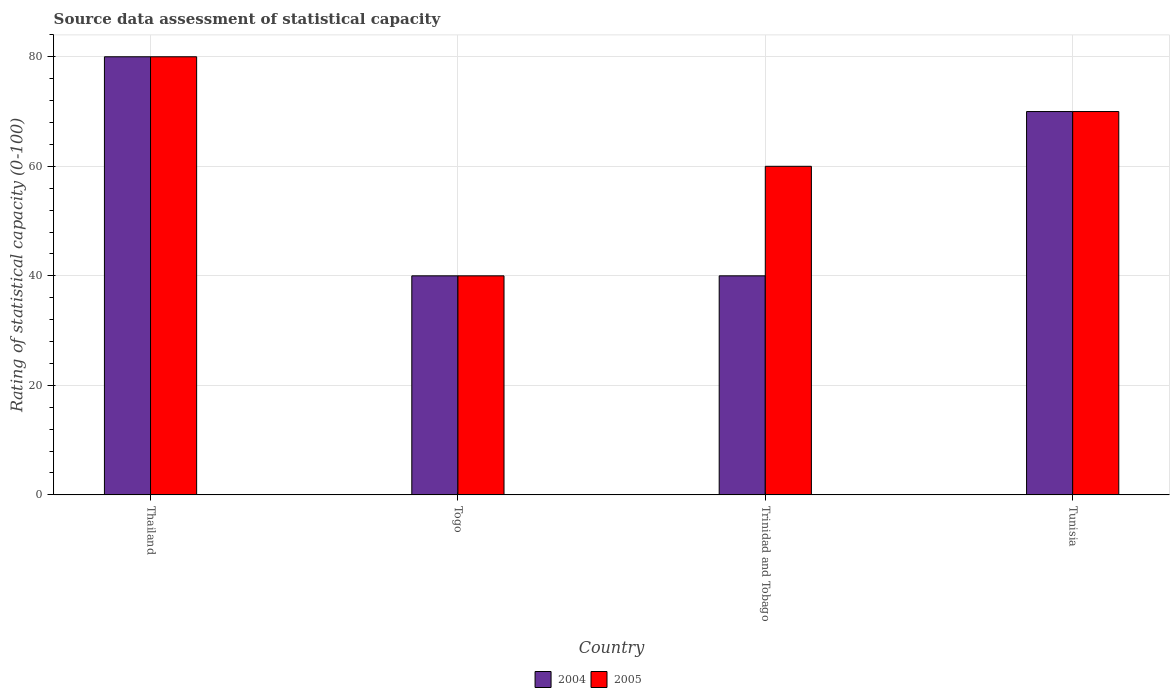Are the number of bars per tick equal to the number of legend labels?
Your answer should be compact. Yes. How many bars are there on the 3rd tick from the left?
Keep it short and to the point. 2. What is the label of the 1st group of bars from the left?
Keep it short and to the point. Thailand. In how many cases, is the number of bars for a given country not equal to the number of legend labels?
Provide a succinct answer. 0. What is the rating of statistical capacity in 2004 in Tunisia?
Give a very brief answer. 70. Across all countries, what is the maximum rating of statistical capacity in 2005?
Your answer should be very brief. 80. Across all countries, what is the minimum rating of statistical capacity in 2004?
Offer a terse response. 40. In which country was the rating of statistical capacity in 2005 maximum?
Your answer should be compact. Thailand. In which country was the rating of statistical capacity in 2005 minimum?
Your answer should be very brief. Togo. What is the total rating of statistical capacity in 2005 in the graph?
Provide a succinct answer. 250. What is the average rating of statistical capacity in 2005 per country?
Your answer should be very brief. 62.5. What is the difference between the rating of statistical capacity of/in 2004 and rating of statistical capacity of/in 2005 in Trinidad and Tobago?
Ensure brevity in your answer.  -20. In how many countries, is the rating of statistical capacity in 2005 greater than 80?
Offer a terse response. 0. Is the rating of statistical capacity in 2004 in Togo less than that in Tunisia?
Provide a succinct answer. Yes. Is the difference between the rating of statistical capacity in 2004 in Thailand and Togo greater than the difference between the rating of statistical capacity in 2005 in Thailand and Togo?
Offer a terse response. No. What is the difference between the highest and the second highest rating of statistical capacity in 2004?
Offer a very short reply. 40. In how many countries, is the rating of statistical capacity in 2005 greater than the average rating of statistical capacity in 2005 taken over all countries?
Your response must be concise. 2. What does the 1st bar from the left in Tunisia represents?
Ensure brevity in your answer.  2004. Are all the bars in the graph horizontal?
Provide a succinct answer. No. How many countries are there in the graph?
Make the answer very short. 4. What is the difference between two consecutive major ticks on the Y-axis?
Provide a succinct answer. 20. Are the values on the major ticks of Y-axis written in scientific E-notation?
Your response must be concise. No. Does the graph contain any zero values?
Provide a succinct answer. No. Does the graph contain grids?
Ensure brevity in your answer.  Yes. How are the legend labels stacked?
Provide a short and direct response. Horizontal. What is the title of the graph?
Your response must be concise. Source data assessment of statistical capacity. What is the label or title of the Y-axis?
Offer a very short reply. Rating of statistical capacity (0-100). What is the Rating of statistical capacity (0-100) in 2004 in Thailand?
Keep it short and to the point. 80. What is the Rating of statistical capacity (0-100) in 2004 in Togo?
Your response must be concise. 40. What is the Rating of statistical capacity (0-100) in 2005 in Togo?
Offer a very short reply. 40. What is the Rating of statistical capacity (0-100) in 2004 in Trinidad and Tobago?
Offer a terse response. 40. Across all countries, what is the maximum Rating of statistical capacity (0-100) of 2005?
Your response must be concise. 80. Across all countries, what is the minimum Rating of statistical capacity (0-100) of 2004?
Offer a very short reply. 40. What is the total Rating of statistical capacity (0-100) of 2004 in the graph?
Provide a succinct answer. 230. What is the total Rating of statistical capacity (0-100) in 2005 in the graph?
Provide a short and direct response. 250. What is the difference between the Rating of statistical capacity (0-100) in 2005 in Thailand and that in Togo?
Provide a succinct answer. 40. What is the difference between the Rating of statistical capacity (0-100) in 2004 in Thailand and that in Trinidad and Tobago?
Your answer should be compact. 40. What is the difference between the Rating of statistical capacity (0-100) in 2005 in Togo and that in Trinidad and Tobago?
Give a very brief answer. -20. What is the difference between the Rating of statistical capacity (0-100) of 2004 in Togo and that in Tunisia?
Give a very brief answer. -30. What is the difference between the Rating of statistical capacity (0-100) in 2005 in Trinidad and Tobago and that in Tunisia?
Give a very brief answer. -10. What is the difference between the Rating of statistical capacity (0-100) of 2004 in Thailand and the Rating of statistical capacity (0-100) of 2005 in Togo?
Keep it short and to the point. 40. What is the difference between the Rating of statistical capacity (0-100) in 2004 in Thailand and the Rating of statistical capacity (0-100) in 2005 in Trinidad and Tobago?
Your answer should be very brief. 20. What is the difference between the Rating of statistical capacity (0-100) in 2004 in Thailand and the Rating of statistical capacity (0-100) in 2005 in Tunisia?
Give a very brief answer. 10. What is the average Rating of statistical capacity (0-100) of 2004 per country?
Offer a terse response. 57.5. What is the average Rating of statistical capacity (0-100) of 2005 per country?
Ensure brevity in your answer.  62.5. What is the difference between the Rating of statistical capacity (0-100) in 2004 and Rating of statistical capacity (0-100) in 2005 in Thailand?
Your response must be concise. 0. What is the difference between the Rating of statistical capacity (0-100) of 2004 and Rating of statistical capacity (0-100) of 2005 in Togo?
Offer a terse response. 0. What is the ratio of the Rating of statistical capacity (0-100) of 2004 in Thailand to that in Trinidad and Tobago?
Make the answer very short. 2. What is the ratio of the Rating of statistical capacity (0-100) in 2004 in Thailand to that in Tunisia?
Ensure brevity in your answer.  1.14. What is the ratio of the Rating of statistical capacity (0-100) of 2004 in Togo to that in Trinidad and Tobago?
Keep it short and to the point. 1. What is the ratio of the Rating of statistical capacity (0-100) in 2005 in Togo to that in Trinidad and Tobago?
Ensure brevity in your answer.  0.67. What is the ratio of the Rating of statistical capacity (0-100) in 2004 in Togo to that in Tunisia?
Offer a terse response. 0.57. What is the ratio of the Rating of statistical capacity (0-100) of 2005 in Togo to that in Tunisia?
Provide a succinct answer. 0.57. What is the difference between the highest and the lowest Rating of statistical capacity (0-100) of 2005?
Keep it short and to the point. 40. 